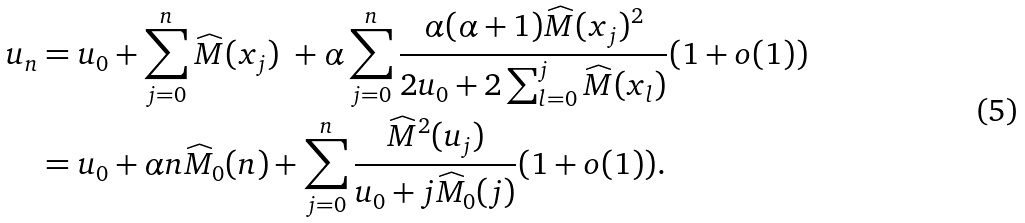Convert formula to latex. <formula><loc_0><loc_0><loc_500><loc_500>u _ { n } & = u _ { 0 } + \sum _ { j = 0 } ^ { n } \widehat { M } ( x _ { j } ) \ + \alpha \sum _ { j = 0 } ^ { n } \frac { \alpha ( \alpha + 1 ) \widehat { M } ( x _ { j } ) ^ { 2 } } { 2 u _ { 0 } + 2 \sum _ { l = 0 } ^ { j } \widehat { M } ( x _ { l } ) } ( 1 + o ( 1 ) ) \\ & = u _ { 0 } + \alpha n \widehat { M } _ { 0 } ( n ) + \sum _ { j = 0 } ^ { n } \frac { \widehat { M } ^ { 2 } ( u _ { j } ) } { u _ { 0 } + j \widehat { M } _ { 0 } ( j ) } ( 1 + o ( 1 ) ) .</formula> 